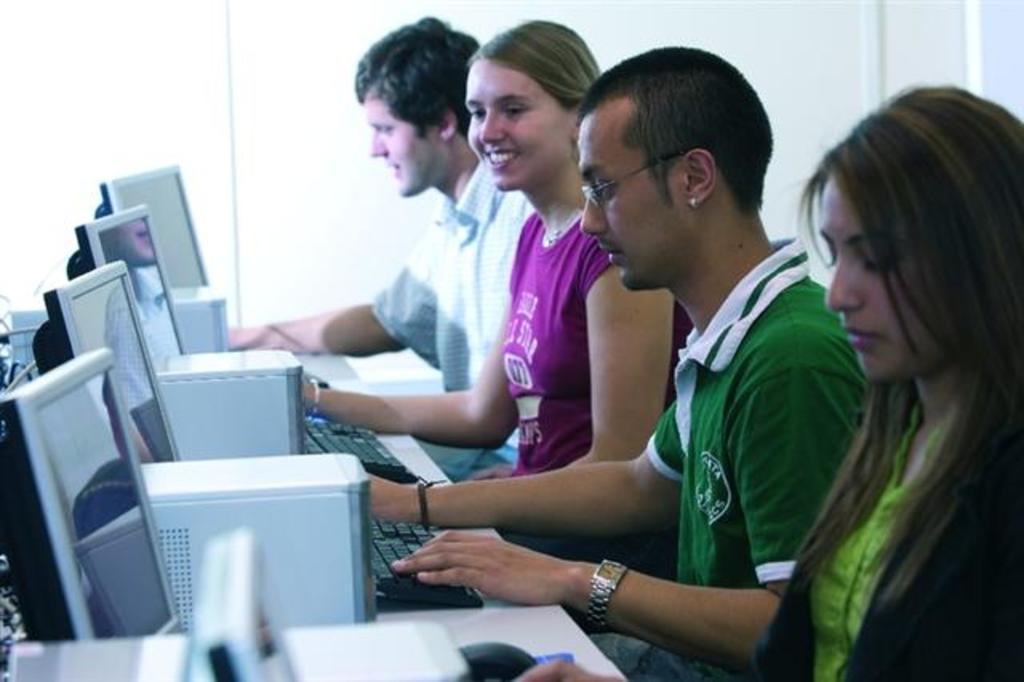Please provide a concise description of this image. In this picture I can see four persons sitting, there are monitors, PC desktops, keyboards and a mouse on the table, and there is white background. 